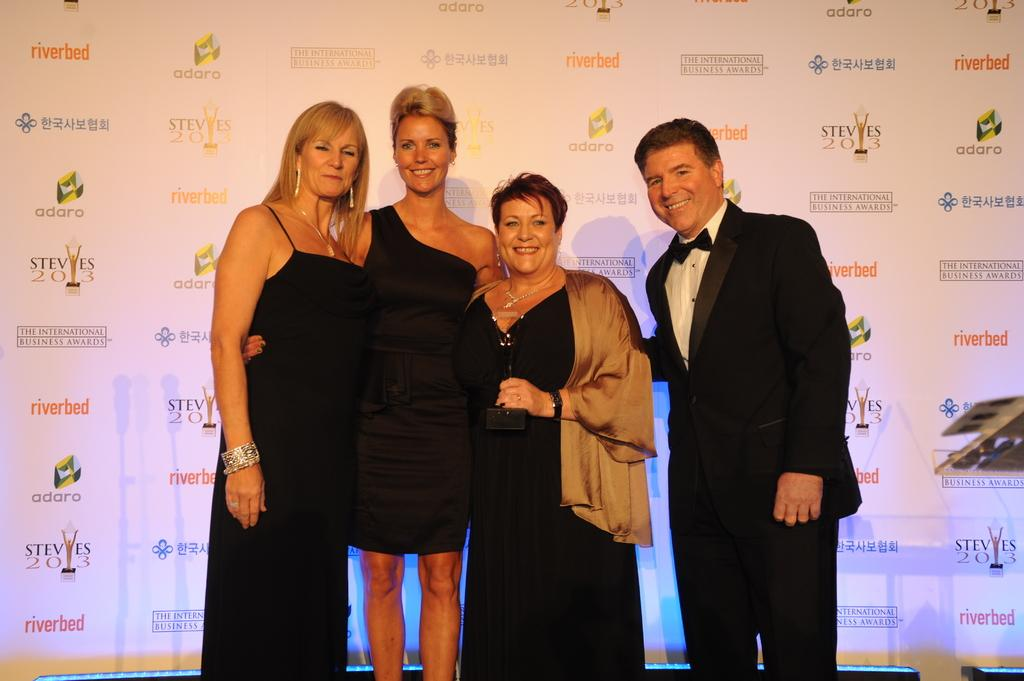Who is present in the image? There are people in the image. What are the people doing in the image? The people are smiling. What else can be seen in the image besides the people? There is a banner in the image. What information is displayed on the banner? The banner has a sponsor's name on it. What hobbies do the people on the island have? There is no mention of an island in the image, and therefore no information about the people's hobbies can be provided. 